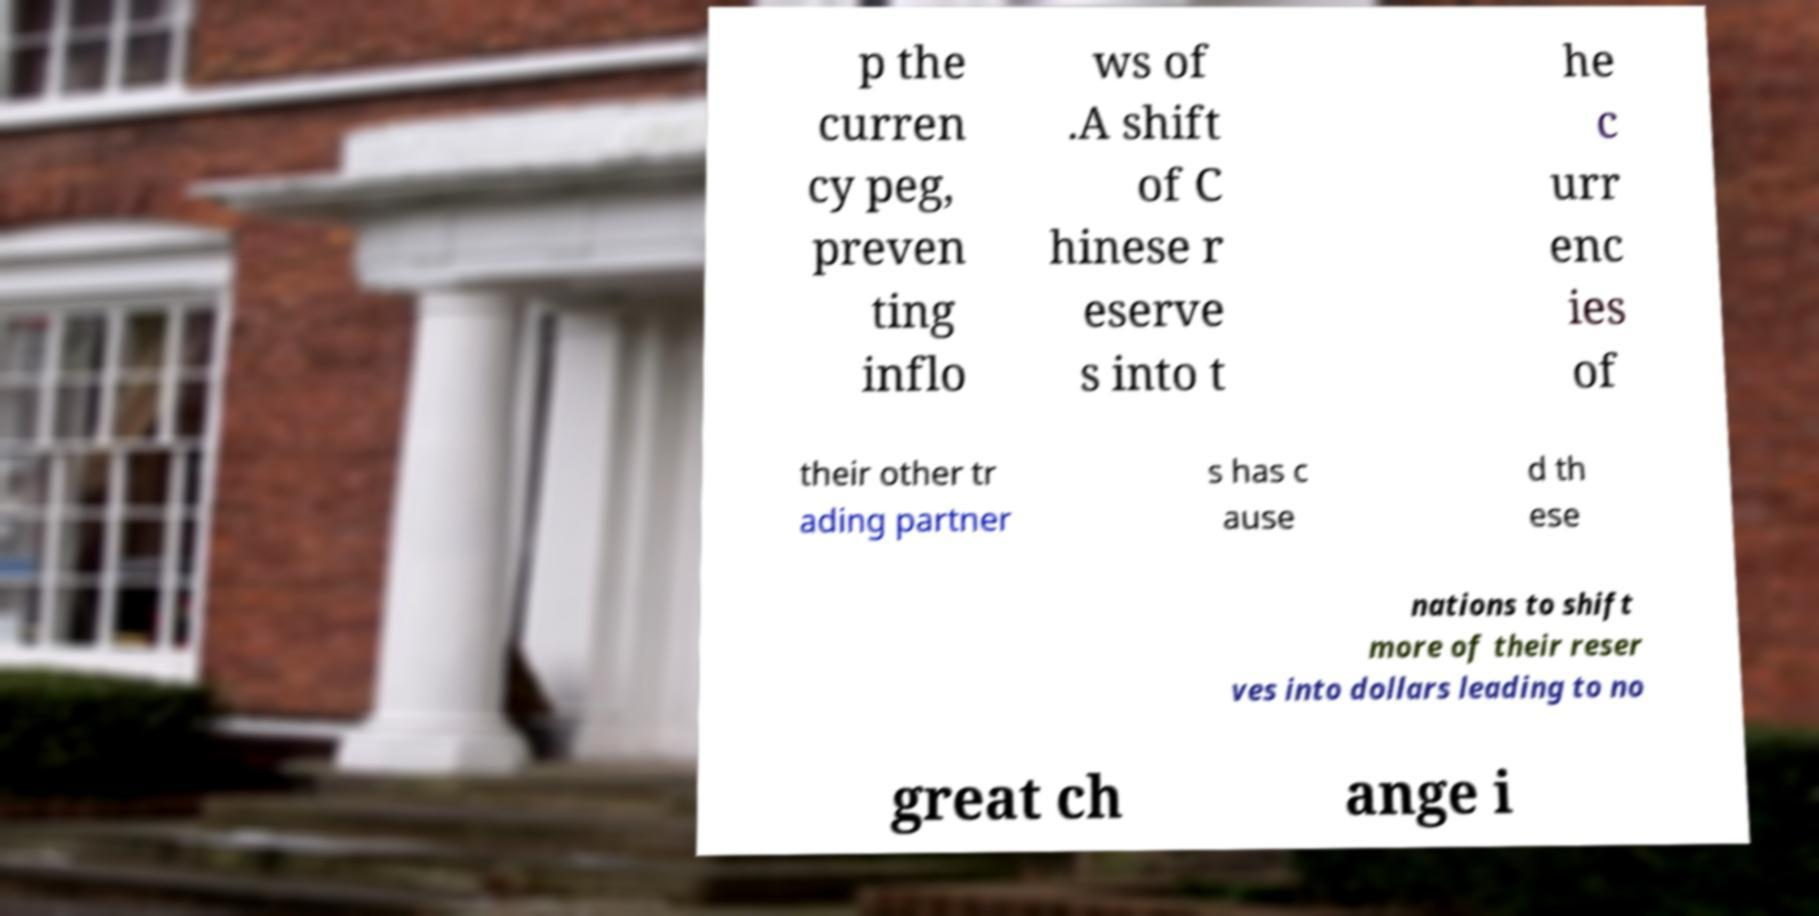Could you assist in decoding the text presented in this image and type it out clearly? p the curren cy peg, preven ting inflo ws of .A shift of C hinese r eserve s into t he c urr enc ies of their other tr ading partner s has c ause d th ese nations to shift more of their reser ves into dollars leading to no great ch ange i 